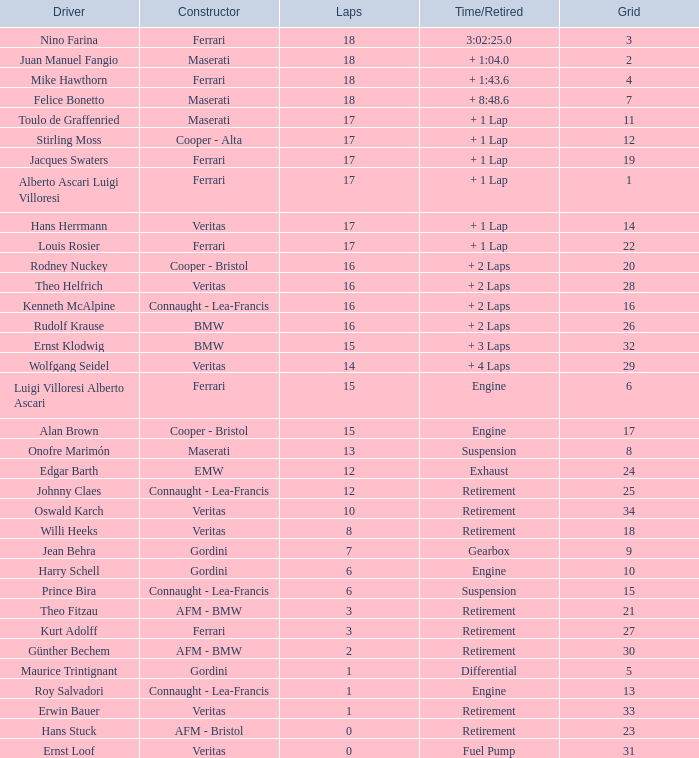Who possesses the least lap sum in a maserati within grid 2? 18.0. 